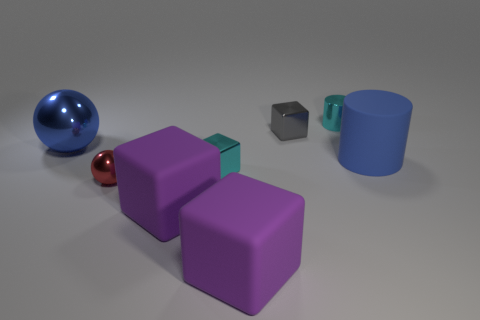Subtract all cyan cubes. How many cubes are left? 3 Add 2 gray objects. How many objects exist? 10 Subtract all cyan blocks. How many blocks are left? 3 Subtract all cylinders. How many objects are left? 6 Add 3 tiny shiny things. How many tiny shiny things are left? 7 Add 4 gray metallic cylinders. How many gray metallic cylinders exist? 4 Subtract 0 gray cylinders. How many objects are left? 8 Subtract 2 blocks. How many blocks are left? 2 Subtract all gray cylinders. Subtract all blue spheres. How many cylinders are left? 2 Subtract all red balls. How many cyan blocks are left? 1 